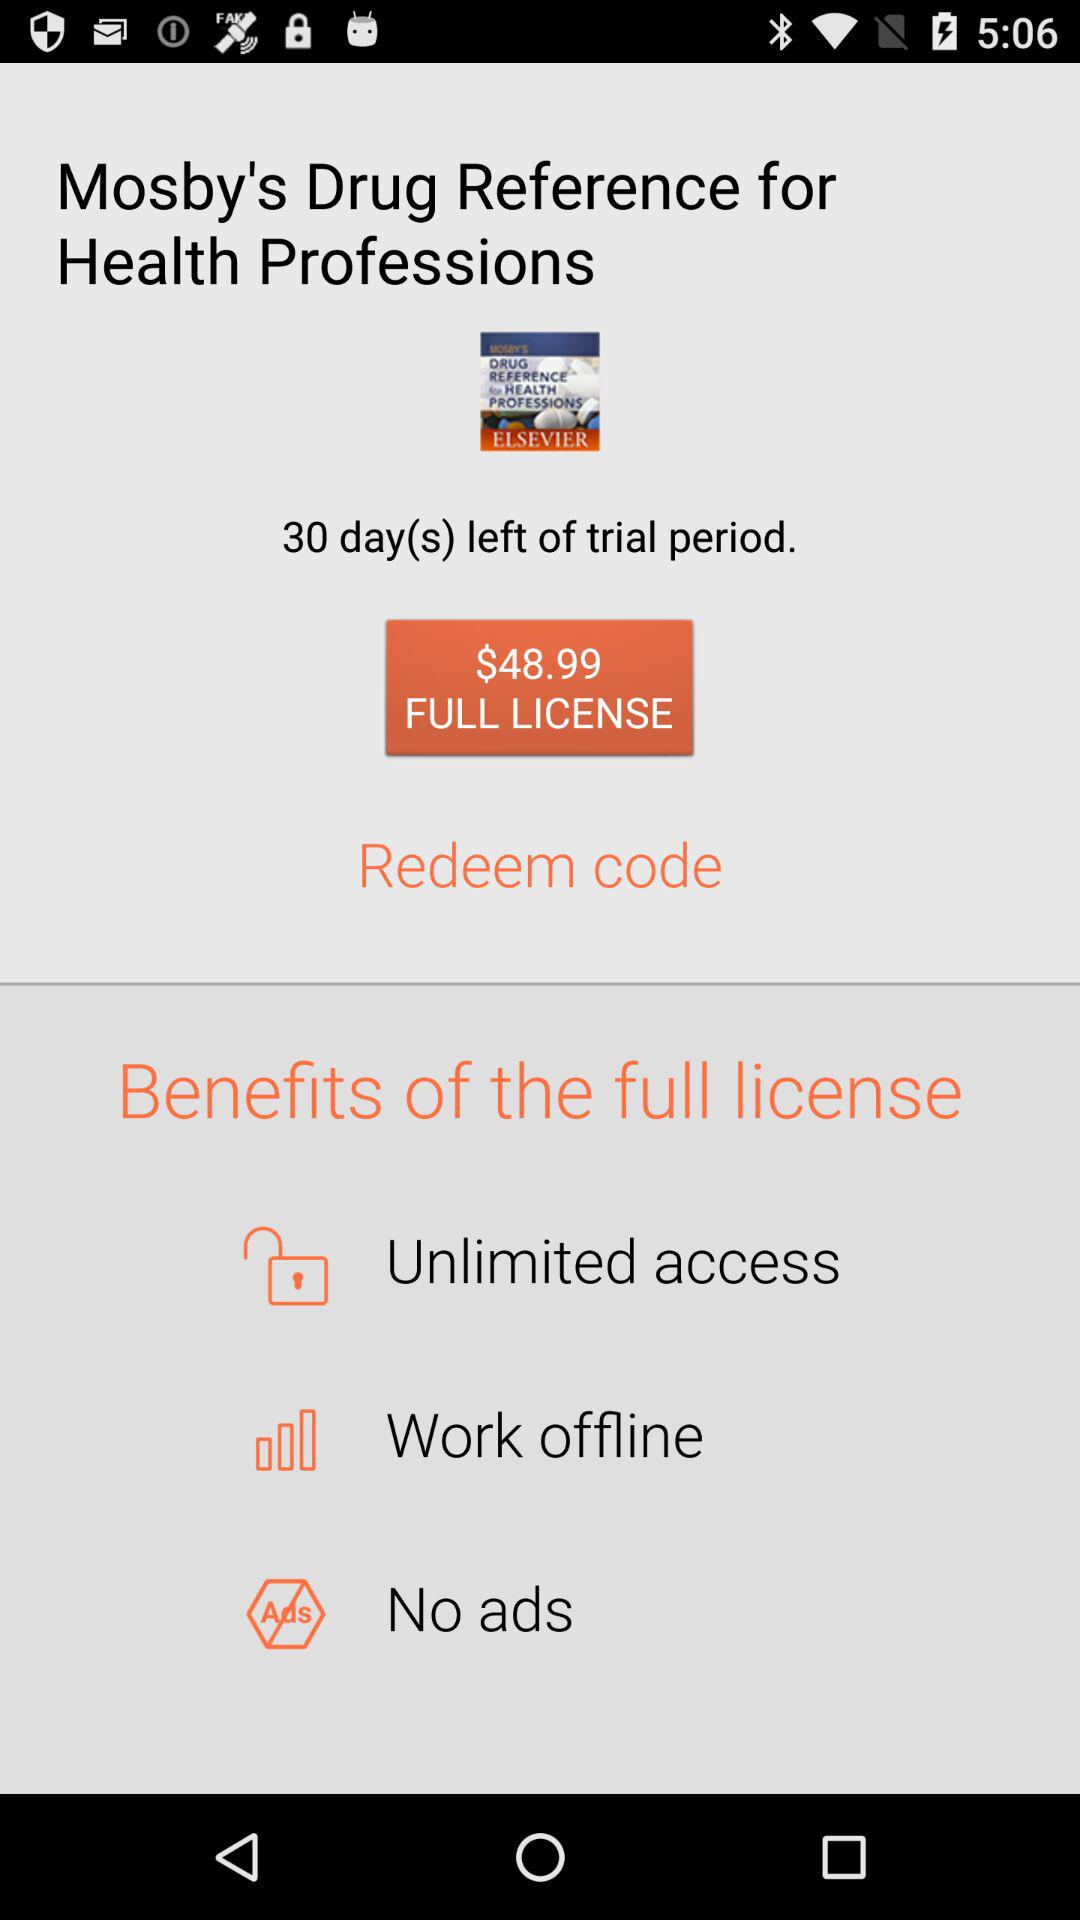What's the cost of the full license? The cost is $48.99. 